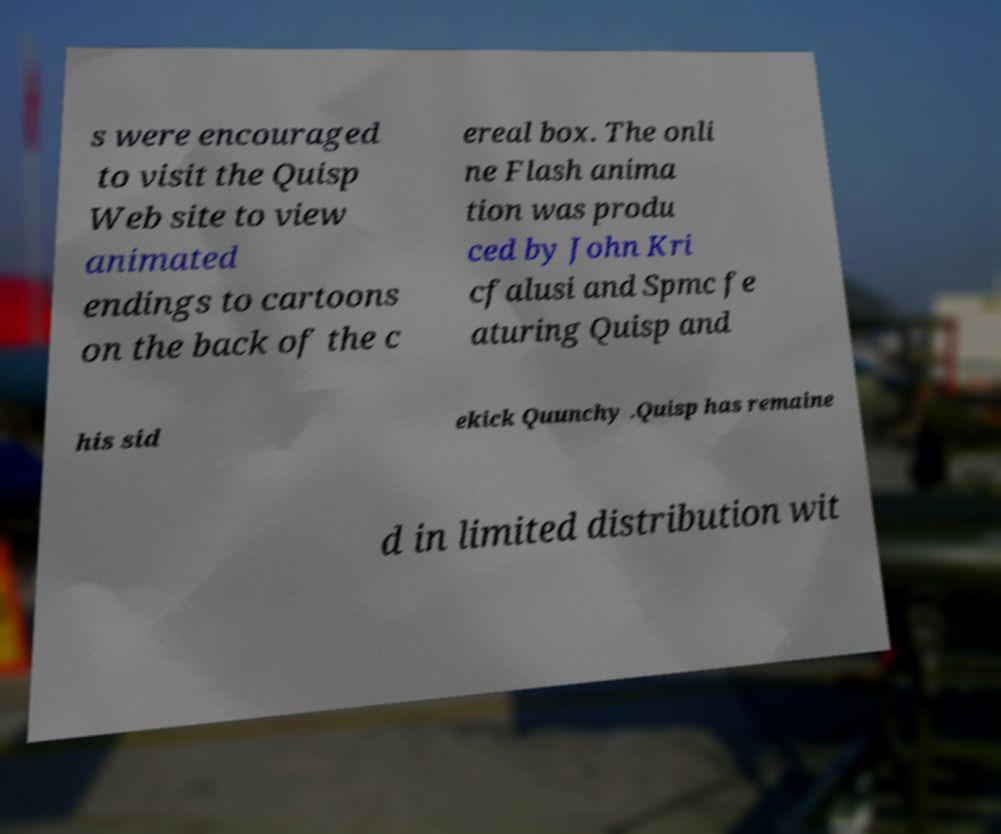There's text embedded in this image that I need extracted. Can you transcribe it verbatim? s were encouraged to visit the Quisp Web site to view animated endings to cartoons on the back of the c ereal box. The onli ne Flash anima tion was produ ced by John Kri cfalusi and Spmc fe aturing Quisp and his sid ekick Quunchy .Quisp has remaine d in limited distribution wit 